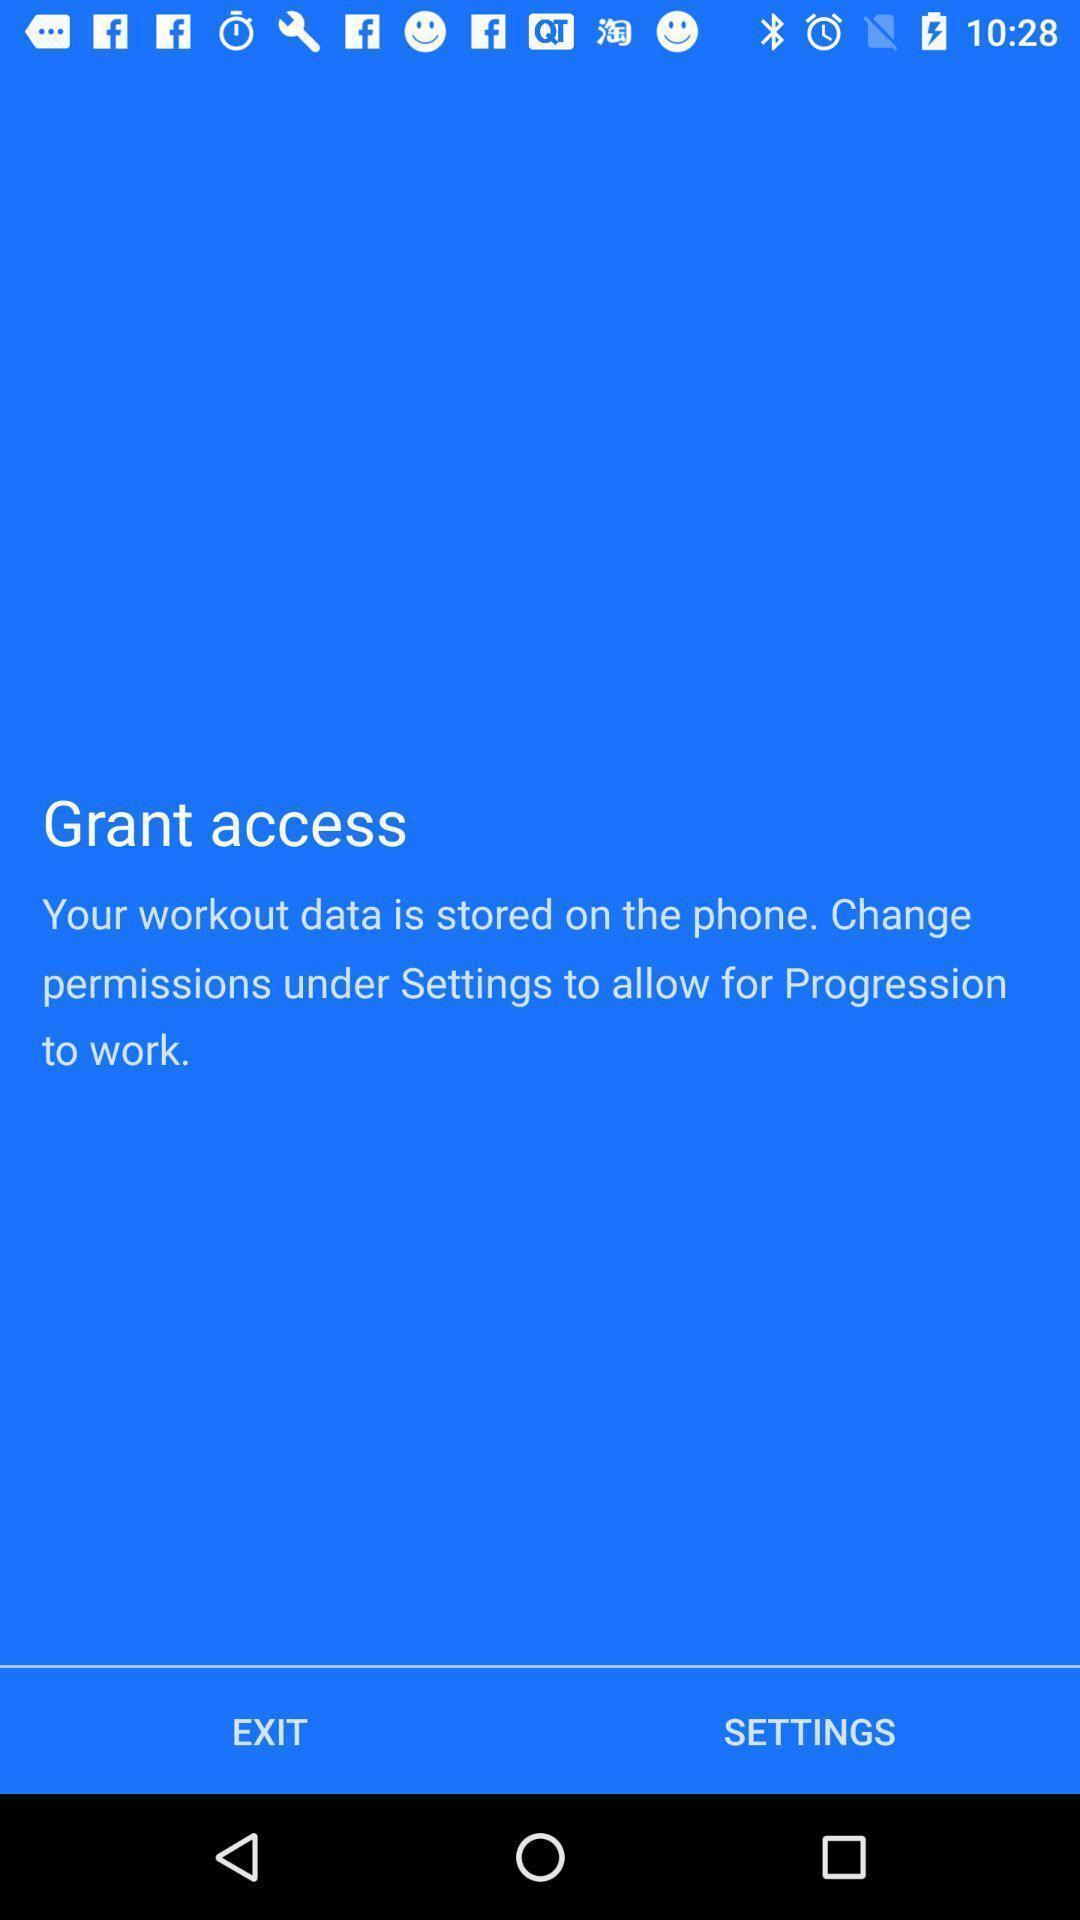Describe this image in words. Window asking permission for fitness app. 